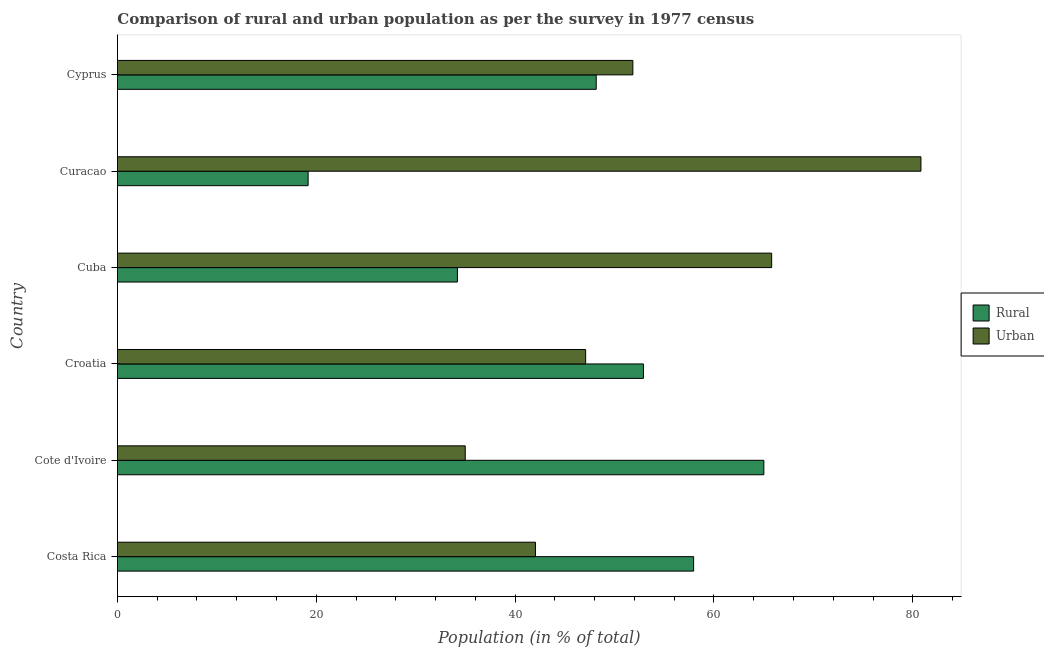How many different coloured bars are there?
Offer a terse response. 2. Are the number of bars per tick equal to the number of legend labels?
Ensure brevity in your answer.  Yes. Are the number of bars on each tick of the Y-axis equal?
Offer a very short reply. Yes. How many bars are there on the 1st tick from the bottom?
Offer a very short reply. 2. What is the label of the 2nd group of bars from the top?
Your answer should be very brief. Curacao. What is the urban population in Costa Rica?
Your response must be concise. 42.05. Across all countries, what is the maximum rural population?
Offer a very short reply. 65.02. Across all countries, what is the minimum urban population?
Your answer should be very brief. 34.98. In which country was the rural population maximum?
Ensure brevity in your answer.  Cote d'Ivoire. In which country was the urban population minimum?
Ensure brevity in your answer.  Cote d'Ivoire. What is the total urban population in the graph?
Offer a very short reply. 322.58. What is the difference between the rural population in Costa Rica and that in Curacao?
Your answer should be compact. 38.77. What is the difference between the urban population in Costa Rica and the rural population in Cuba?
Provide a short and direct response. 7.85. What is the average urban population per country?
Keep it short and to the point. 53.76. What is the difference between the rural population and urban population in Croatia?
Your response must be concise. 5.81. What is the ratio of the rural population in Cuba to that in Curacao?
Offer a very short reply. 1.78. What is the difference between the highest and the second highest rural population?
Ensure brevity in your answer.  7.06. What is the difference between the highest and the lowest rural population?
Keep it short and to the point. 45.83. Is the sum of the rural population in Curacao and Cyprus greater than the maximum urban population across all countries?
Keep it short and to the point. No. What does the 1st bar from the top in Croatia represents?
Keep it short and to the point. Urban. What does the 1st bar from the bottom in Croatia represents?
Offer a very short reply. Rural. How many bars are there?
Offer a very short reply. 12. Are all the bars in the graph horizontal?
Provide a short and direct response. Yes. Does the graph contain any zero values?
Provide a succinct answer. No. Where does the legend appear in the graph?
Your answer should be compact. Center right. How many legend labels are there?
Offer a very short reply. 2. How are the legend labels stacked?
Your response must be concise. Vertical. What is the title of the graph?
Your answer should be very brief. Comparison of rural and urban population as per the survey in 1977 census. What is the label or title of the X-axis?
Make the answer very short. Population (in % of total). What is the Population (in % of total) in Rural in Costa Rica?
Your answer should be very brief. 57.95. What is the Population (in % of total) in Urban in Costa Rica?
Give a very brief answer. 42.05. What is the Population (in % of total) in Rural in Cote d'Ivoire?
Offer a very short reply. 65.02. What is the Population (in % of total) in Urban in Cote d'Ivoire?
Keep it short and to the point. 34.98. What is the Population (in % of total) in Rural in Croatia?
Offer a very short reply. 52.91. What is the Population (in % of total) of Urban in Croatia?
Your response must be concise. 47.09. What is the Population (in % of total) of Rural in Cuba?
Offer a terse response. 34.2. What is the Population (in % of total) of Urban in Cuba?
Ensure brevity in your answer.  65.8. What is the Population (in % of total) in Rural in Curacao?
Provide a short and direct response. 19.18. What is the Population (in % of total) in Urban in Curacao?
Offer a terse response. 80.82. What is the Population (in % of total) in Rural in Cyprus?
Make the answer very short. 48.16. What is the Population (in % of total) in Urban in Cyprus?
Your answer should be compact. 51.84. Across all countries, what is the maximum Population (in % of total) of Rural?
Provide a short and direct response. 65.02. Across all countries, what is the maximum Population (in % of total) of Urban?
Make the answer very short. 80.82. Across all countries, what is the minimum Population (in % of total) in Rural?
Offer a terse response. 19.18. Across all countries, what is the minimum Population (in % of total) of Urban?
Make the answer very short. 34.98. What is the total Population (in % of total) in Rural in the graph?
Give a very brief answer. 277.42. What is the total Population (in % of total) in Urban in the graph?
Keep it short and to the point. 322.58. What is the difference between the Population (in % of total) of Rural in Costa Rica and that in Cote d'Ivoire?
Give a very brief answer. -7.06. What is the difference between the Population (in % of total) of Urban in Costa Rica and that in Cote d'Ivoire?
Give a very brief answer. 7.06. What is the difference between the Population (in % of total) in Rural in Costa Rica and that in Croatia?
Your answer should be compact. 5.05. What is the difference between the Population (in % of total) in Urban in Costa Rica and that in Croatia?
Your answer should be very brief. -5.05. What is the difference between the Population (in % of total) in Rural in Costa Rica and that in Cuba?
Ensure brevity in your answer.  23.76. What is the difference between the Population (in % of total) in Urban in Costa Rica and that in Cuba?
Offer a terse response. -23.76. What is the difference between the Population (in % of total) of Rural in Costa Rica and that in Curacao?
Your response must be concise. 38.77. What is the difference between the Population (in % of total) in Urban in Costa Rica and that in Curacao?
Your answer should be compact. -38.77. What is the difference between the Population (in % of total) in Rural in Costa Rica and that in Cyprus?
Make the answer very short. 9.8. What is the difference between the Population (in % of total) of Urban in Costa Rica and that in Cyprus?
Give a very brief answer. -9.8. What is the difference between the Population (in % of total) of Rural in Cote d'Ivoire and that in Croatia?
Your answer should be very brief. 12.11. What is the difference between the Population (in % of total) of Urban in Cote d'Ivoire and that in Croatia?
Give a very brief answer. -12.11. What is the difference between the Population (in % of total) in Rural in Cote d'Ivoire and that in Cuba?
Your response must be concise. 30.82. What is the difference between the Population (in % of total) of Urban in Cote d'Ivoire and that in Cuba?
Keep it short and to the point. -30.82. What is the difference between the Population (in % of total) of Rural in Cote d'Ivoire and that in Curacao?
Provide a short and direct response. 45.83. What is the difference between the Population (in % of total) in Urban in Cote d'Ivoire and that in Curacao?
Provide a short and direct response. -45.83. What is the difference between the Population (in % of total) of Rural in Cote d'Ivoire and that in Cyprus?
Give a very brief answer. 16.86. What is the difference between the Population (in % of total) of Urban in Cote d'Ivoire and that in Cyprus?
Provide a short and direct response. -16.86. What is the difference between the Population (in % of total) in Rural in Croatia and that in Cuba?
Your response must be concise. 18.71. What is the difference between the Population (in % of total) of Urban in Croatia and that in Cuba?
Your answer should be compact. -18.71. What is the difference between the Population (in % of total) of Rural in Croatia and that in Curacao?
Provide a succinct answer. 33.72. What is the difference between the Population (in % of total) of Urban in Croatia and that in Curacao?
Your answer should be very brief. -33.72. What is the difference between the Population (in % of total) in Rural in Croatia and that in Cyprus?
Keep it short and to the point. 4.75. What is the difference between the Population (in % of total) of Urban in Croatia and that in Cyprus?
Offer a terse response. -4.75. What is the difference between the Population (in % of total) in Rural in Cuba and that in Curacao?
Make the answer very short. 15.02. What is the difference between the Population (in % of total) of Urban in Cuba and that in Curacao?
Offer a terse response. -15.02. What is the difference between the Population (in % of total) of Rural in Cuba and that in Cyprus?
Your response must be concise. -13.96. What is the difference between the Population (in % of total) in Urban in Cuba and that in Cyprus?
Offer a terse response. 13.96. What is the difference between the Population (in % of total) in Rural in Curacao and that in Cyprus?
Provide a short and direct response. -28.97. What is the difference between the Population (in % of total) of Urban in Curacao and that in Cyprus?
Your answer should be very brief. 28.97. What is the difference between the Population (in % of total) of Rural in Costa Rica and the Population (in % of total) of Urban in Cote d'Ivoire?
Offer a terse response. 22.97. What is the difference between the Population (in % of total) of Rural in Costa Rica and the Population (in % of total) of Urban in Croatia?
Make the answer very short. 10.86. What is the difference between the Population (in % of total) of Rural in Costa Rica and the Population (in % of total) of Urban in Cuba?
Your response must be concise. -7.85. What is the difference between the Population (in % of total) of Rural in Costa Rica and the Population (in % of total) of Urban in Curacao?
Keep it short and to the point. -22.86. What is the difference between the Population (in % of total) of Rural in Costa Rica and the Population (in % of total) of Urban in Cyprus?
Your answer should be very brief. 6.11. What is the difference between the Population (in % of total) in Rural in Cote d'Ivoire and the Population (in % of total) in Urban in Croatia?
Offer a terse response. 17.92. What is the difference between the Population (in % of total) of Rural in Cote d'Ivoire and the Population (in % of total) of Urban in Cuba?
Give a very brief answer. -0.79. What is the difference between the Population (in % of total) in Rural in Cote d'Ivoire and the Population (in % of total) in Urban in Curacao?
Make the answer very short. -15.8. What is the difference between the Population (in % of total) of Rural in Cote d'Ivoire and the Population (in % of total) of Urban in Cyprus?
Ensure brevity in your answer.  13.17. What is the difference between the Population (in % of total) of Rural in Croatia and the Population (in % of total) of Urban in Cuba?
Offer a terse response. -12.89. What is the difference between the Population (in % of total) in Rural in Croatia and the Population (in % of total) in Urban in Curacao?
Give a very brief answer. -27.91. What is the difference between the Population (in % of total) in Rural in Croatia and the Population (in % of total) in Urban in Cyprus?
Your answer should be compact. 1.06. What is the difference between the Population (in % of total) in Rural in Cuba and the Population (in % of total) in Urban in Curacao?
Make the answer very short. -46.62. What is the difference between the Population (in % of total) in Rural in Cuba and the Population (in % of total) in Urban in Cyprus?
Keep it short and to the point. -17.64. What is the difference between the Population (in % of total) in Rural in Curacao and the Population (in % of total) in Urban in Cyprus?
Ensure brevity in your answer.  -32.66. What is the average Population (in % of total) of Rural per country?
Your answer should be very brief. 46.24. What is the average Population (in % of total) in Urban per country?
Give a very brief answer. 53.76. What is the difference between the Population (in % of total) in Rural and Population (in % of total) in Urban in Costa Rica?
Keep it short and to the point. 15.91. What is the difference between the Population (in % of total) of Rural and Population (in % of total) of Urban in Cote d'Ivoire?
Provide a succinct answer. 30.03. What is the difference between the Population (in % of total) of Rural and Population (in % of total) of Urban in Croatia?
Your answer should be very brief. 5.81. What is the difference between the Population (in % of total) of Rural and Population (in % of total) of Urban in Cuba?
Your response must be concise. -31.6. What is the difference between the Population (in % of total) of Rural and Population (in % of total) of Urban in Curacao?
Offer a very short reply. -61.63. What is the difference between the Population (in % of total) in Rural and Population (in % of total) in Urban in Cyprus?
Provide a succinct answer. -3.69. What is the ratio of the Population (in % of total) of Rural in Costa Rica to that in Cote d'Ivoire?
Offer a terse response. 0.89. What is the ratio of the Population (in % of total) of Urban in Costa Rica to that in Cote d'Ivoire?
Ensure brevity in your answer.  1.2. What is the ratio of the Population (in % of total) in Rural in Costa Rica to that in Croatia?
Give a very brief answer. 1.1. What is the ratio of the Population (in % of total) in Urban in Costa Rica to that in Croatia?
Your answer should be compact. 0.89. What is the ratio of the Population (in % of total) in Rural in Costa Rica to that in Cuba?
Offer a terse response. 1.69. What is the ratio of the Population (in % of total) of Urban in Costa Rica to that in Cuba?
Your answer should be compact. 0.64. What is the ratio of the Population (in % of total) of Rural in Costa Rica to that in Curacao?
Keep it short and to the point. 3.02. What is the ratio of the Population (in % of total) of Urban in Costa Rica to that in Curacao?
Offer a very short reply. 0.52. What is the ratio of the Population (in % of total) of Rural in Costa Rica to that in Cyprus?
Make the answer very short. 1.2. What is the ratio of the Population (in % of total) of Urban in Costa Rica to that in Cyprus?
Provide a succinct answer. 0.81. What is the ratio of the Population (in % of total) in Rural in Cote d'Ivoire to that in Croatia?
Provide a short and direct response. 1.23. What is the ratio of the Population (in % of total) in Urban in Cote d'Ivoire to that in Croatia?
Your response must be concise. 0.74. What is the ratio of the Population (in % of total) of Rural in Cote d'Ivoire to that in Cuba?
Your answer should be compact. 1.9. What is the ratio of the Population (in % of total) in Urban in Cote d'Ivoire to that in Cuba?
Give a very brief answer. 0.53. What is the ratio of the Population (in % of total) in Rural in Cote d'Ivoire to that in Curacao?
Make the answer very short. 3.39. What is the ratio of the Population (in % of total) in Urban in Cote d'Ivoire to that in Curacao?
Provide a short and direct response. 0.43. What is the ratio of the Population (in % of total) in Rural in Cote d'Ivoire to that in Cyprus?
Give a very brief answer. 1.35. What is the ratio of the Population (in % of total) of Urban in Cote d'Ivoire to that in Cyprus?
Offer a very short reply. 0.67. What is the ratio of the Population (in % of total) in Rural in Croatia to that in Cuba?
Keep it short and to the point. 1.55. What is the ratio of the Population (in % of total) of Urban in Croatia to that in Cuba?
Keep it short and to the point. 0.72. What is the ratio of the Population (in % of total) of Rural in Croatia to that in Curacao?
Provide a succinct answer. 2.76. What is the ratio of the Population (in % of total) in Urban in Croatia to that in Curacao?
Your answer should be compact. 0.58. What is the ratio of the Population (in % of total) of Rural in Croatia to that in Cyprus?
Keep it short and to the point. 1.1. What is the ratio of the Population (in % of total) in Urban in Croatia to that in Cyprus?
Make the answer very short. 0.91. What is the ratio of the Population (in % of total) of Rural in Cuba to that in Curacao?
Your response must be concise. 1.78. What is the ratio of the Population (in % of total) in Urban in Cuba to that in Curacao?
Make the answer very short. 0.81. What is the ratio of the Population (in % of total) in Rural in Cuba to that in Cyprus?
Provide a short and direct response. 0.71. What is the ratio of the Population (in % of total) of Urban in Cuba to that in Cyprus?
Your answer should be compact. 1.27. What is the ratio of the Population (in % of total) of Rural in Curacao to that in Cyprus?
Give a very brief answer. 0.4. What is the ratio of the Population (in % of total) of Urban in Curacao to that in Cyprus?
Your answer should be compact. 1.56. What is the difference between the highest and the second highest Population (in % of total) of Rural?
Your response must be concise. 7.06. What is the difference between the highest and the second highest Population (in % of total) of Urban?
Keep it short and to the point. 15.02. What is the difference between the highest and the lowest Population (in % of total) in Rural?
Give a very brief answer. 45.83. What is the difference between the highest and the lowest Population (in % of total) of Urban?
Offer a very short reply. 45.83. 